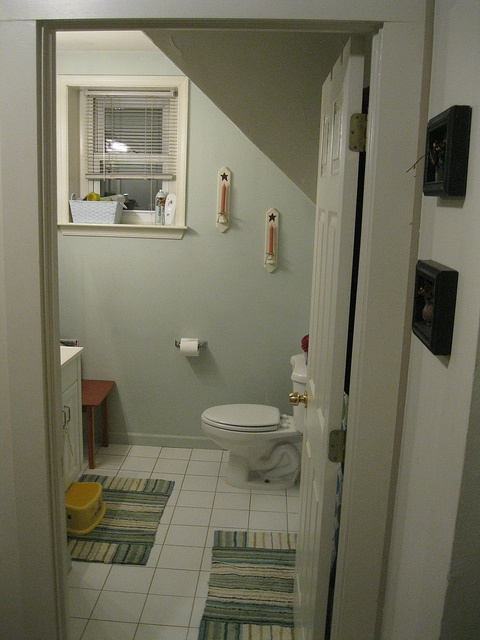Describe the objects in this image and their specific colors. I can see toilet in darkgray, gray, and darkgreen tones, chair in darkgray, maroon, black, and gray tones, and bottle in darkgray and gray tones in this image. 